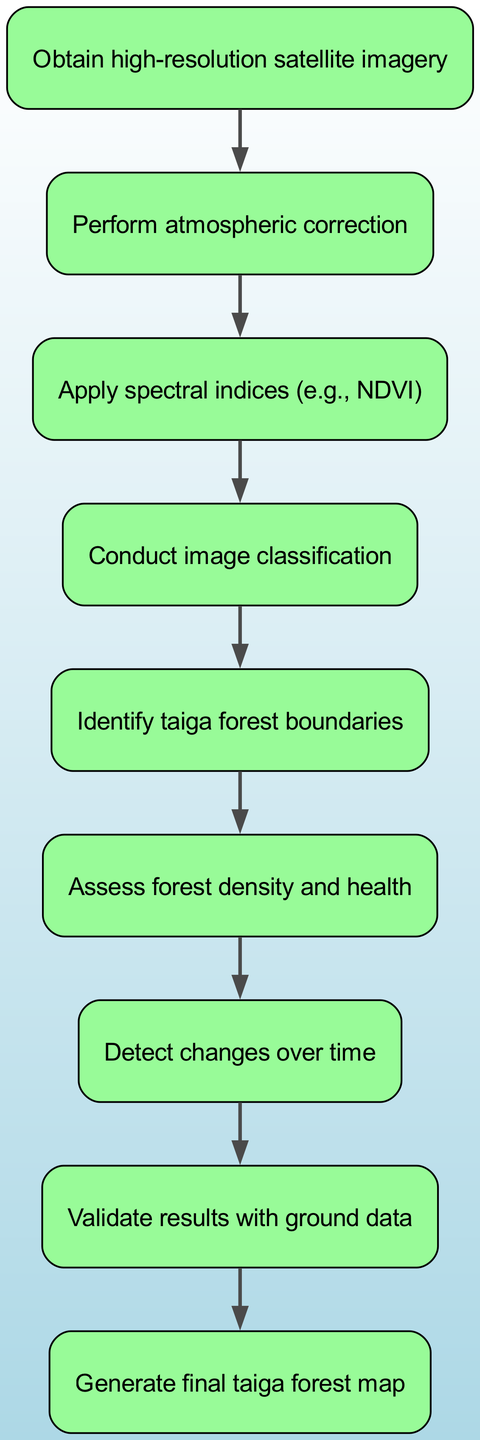What is the first step in analyzing satellite imagery of Russian taiga forests? The diagram indicates that the first step is to "Obtain high-resolution satellite imagery." This is evident as it is the starting node of the flow chart.
Answer: Obtain high-resolution satellite imagery How many total steps are shown in the diagram? By counting each node in the diagram, we find there are nine distinct steps included in the analysis process.
Answer: Nine What is the fifth step in the analysis process? The diagram shows that the fifth step is "Identify taiga forest boundaries." This can be found by locating the fifth node in the flowchart.
Answer: Identify taiga forest boundaries Which step comes directly after conducting image classification? The flowchart indicates that after "Conduct image classification," the next step is "Identify taiga forest boundaries." This follows the flow of connections in the diagram.
Answer: Identify taiga forest boundaries What is the last step in the process of analyzing satellite imagery? The final step as depicted in the diagram is to "Generate final taiga forest map." This is highlighted as the terminal node of the flowchart.
Answer: Generate final taiga forest map What step assesses forest density and health? According to the diagram, the step that assesses forest density and health is labeled as the sixth step, noted as "Assess forest density and health."
Answer: Assess forest density and health How many nodes lead to the validation of results with ground data? The diagram shows that there are two distinct pathways that lead into the "Validate results with ground data" step as it follows the change detection and analysis steps.
Answer: Two What is the relationship between atmospheric correction and the application of spectral indices? The relationship indicated in the diagram shows that "Perform atmospheric correction" must occur before applying spectral indices, as evidenced by the directed flow arrow between the first two nodes.
Answer: Perform atmospheric correction before applying spectral indices Which step detects changes over time? "Detect changes over time" is the seventh step in the flowchart, clearly marked as the node that follows the assessment of forest density and health.
Answer: Detect changes over time 